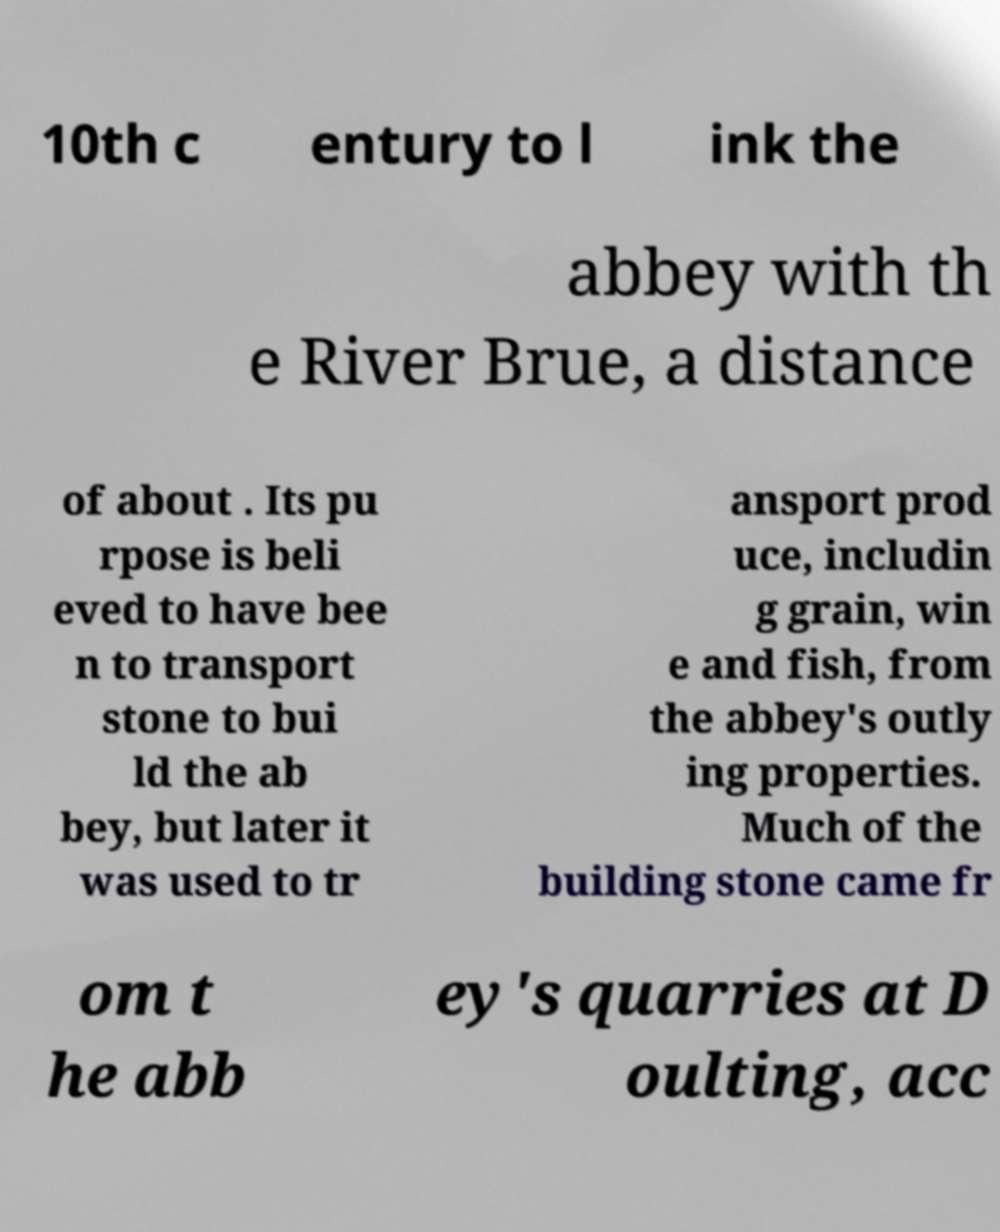Can you accurately transcribe the text from the provided image for me? 10th c entury to l ink the abbey with th e River Brue, a distance of about . Its pu rpose is beli eved to have bee n to transport stone to bui ld the ab bey, but later it was used to tr ansport prod uce, includin g grain, win e and fish, from the abbey's outly ing properties. Much of the building stone came fr om t he abb ey's quarries at D oulting, acc 